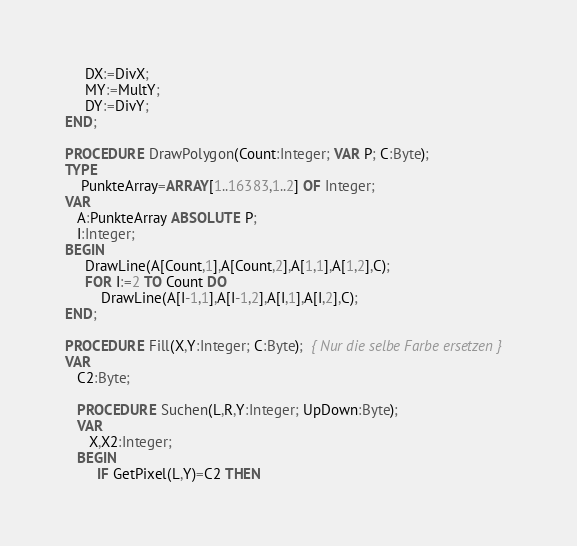<code> <loc_0><loc_0><loc_500><loc_500><_Pascal_>     DX:=DivX;
     MY:=MultY;
     DY:=DivY;
END;

PROCEDURE DrawPolygon(Count:Integer; VAR P; C:Byte);
TYPE
    PunkteArray=ARRAY[1..16383,1..2] OF Integer;
VAR
   A:PunkteArray ABSOLUTE P;
   I:Integer;
BEGIN
     DrawLine(A[Count,1],A[Count,2],A[1,1],A[1,2],C);
     FOR I:=2 TO Count DO
         DrawLine(A[I-1,1],A[I-1,2],A[I,1],A[I,2],C);
END;

PROCEDURE Fill(X,Y:Integer; C:Byte);  { Nur die selbe Farbe ersetzen }
VAR
   C2:Byte;

   PROCEDURE Suchen(L,R,Y:Integer; UpDown:Byte);
   VAR
      X,X2:Integer;
   BEGIN
        IF GetPixel(L,Y)=C2 THEN</code> 